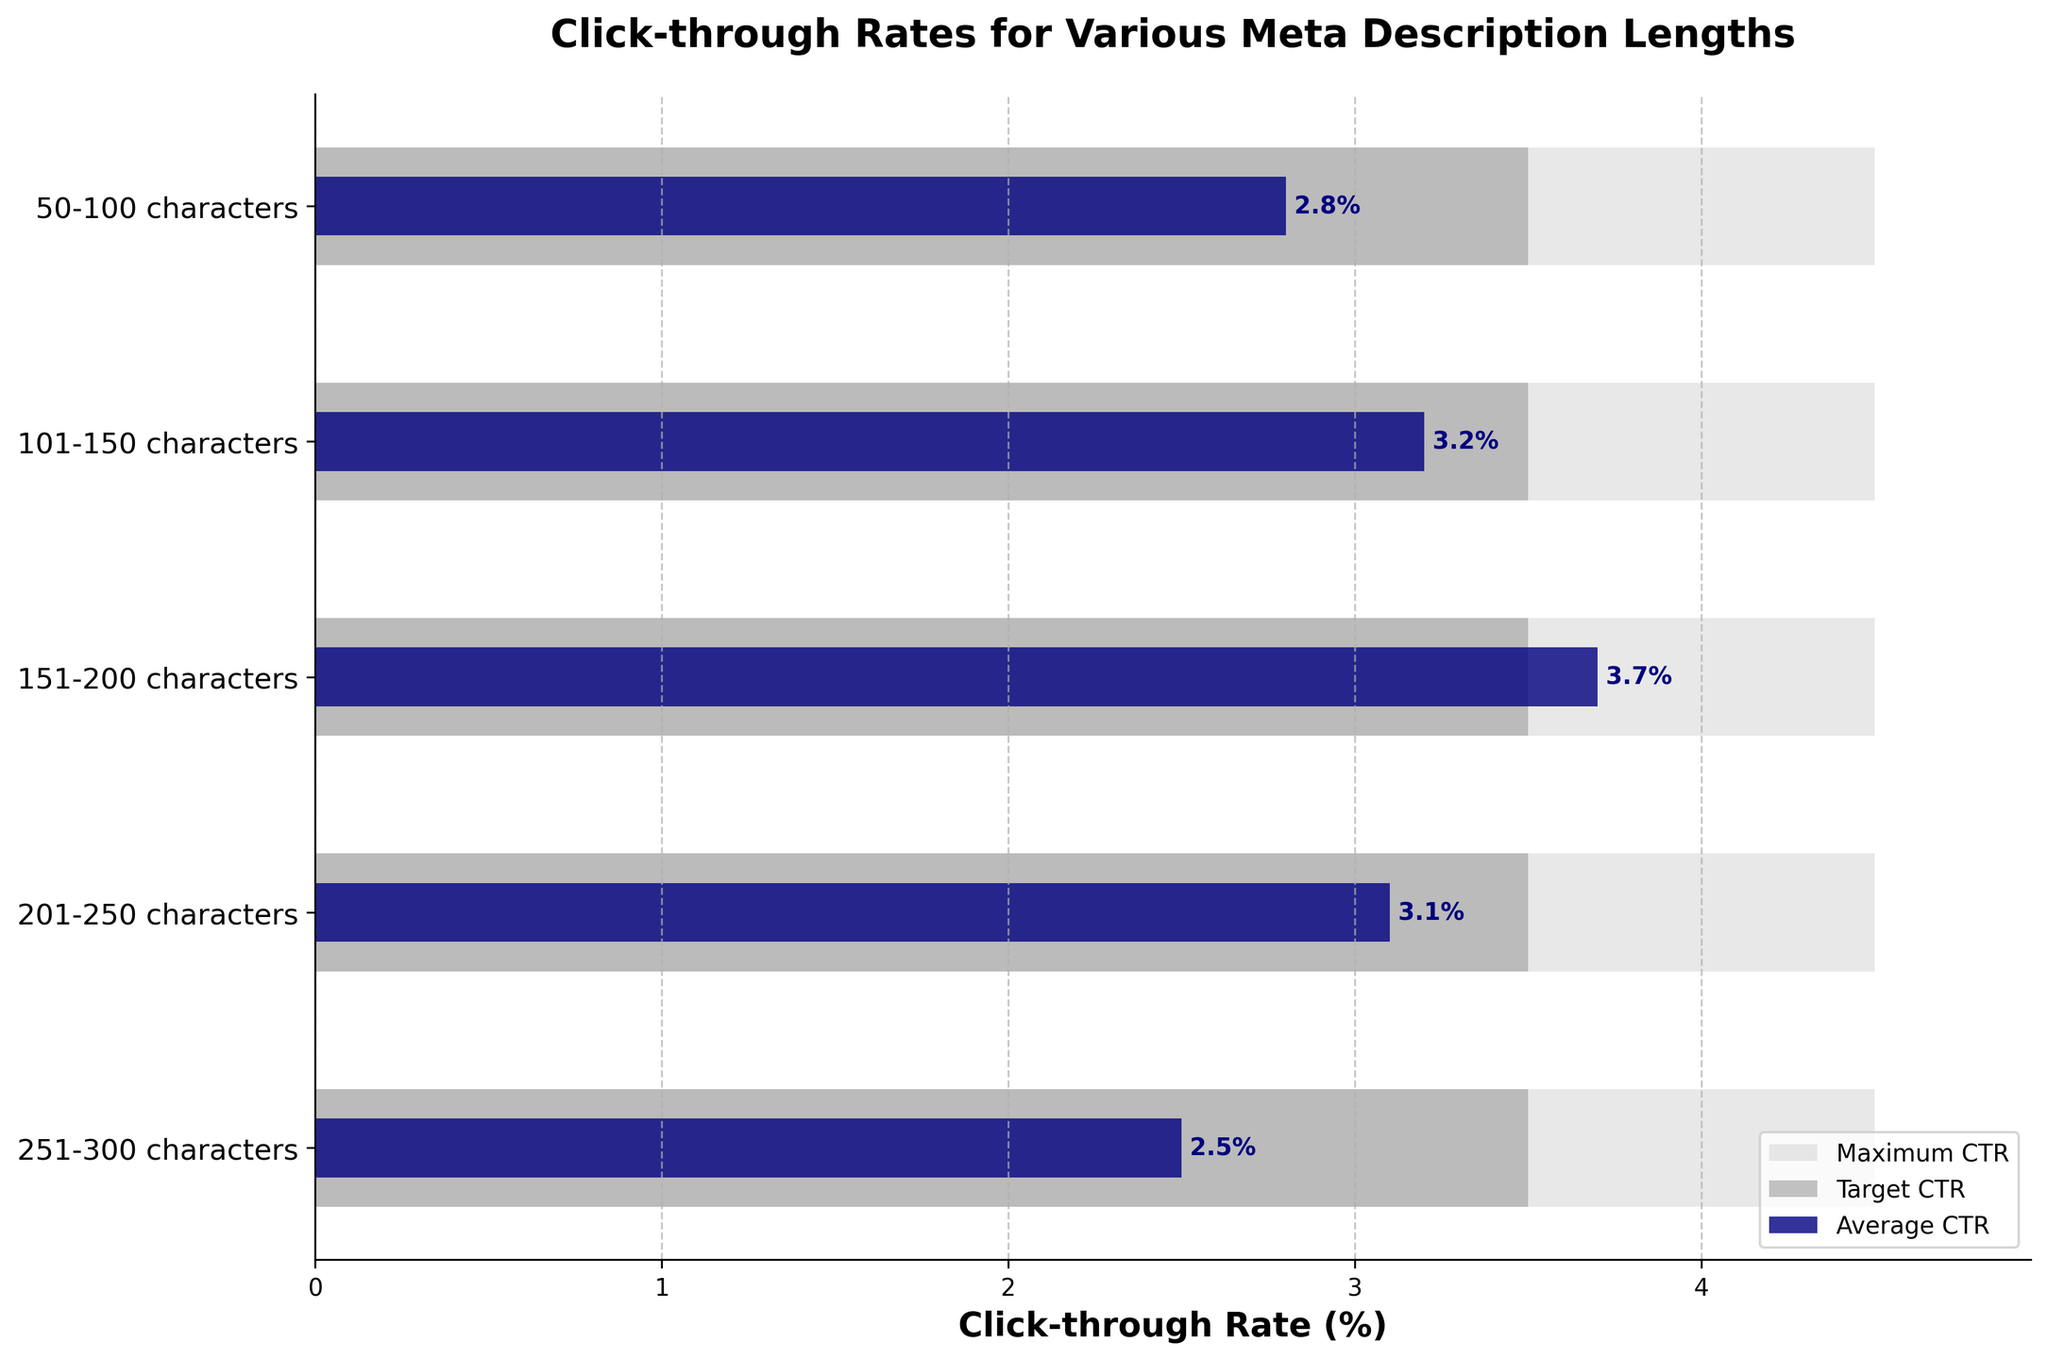What is the title of the chart? The title of the chart is displayed at the top and reads "Click-through Rates for Various Meta Description Lengths."
Answer: Click-through Rates for Various Meta Description Lengths What is the highest click-through rate in the chart? The highest click-through rate in the chart is given by the maximum CTR bar, which all reach up to 4.5%.
Answer: 4.5% How many meta description length categories are shown in the chart? The y-axis shows all the meta description length categories, and there are 5 such categories listed.
Answer: 5 Which meta description length category has the highest average CTR? To find the highest average CTR, we look at the navy-colored bars and see that the "151-200 characters" category has the highest average CTR of 3.7%.
Answer: 151-200 characters Which meta description length category has the lowest average CTR? By inspecting the navy-colored bars, the "251-300 characters" category has the lowest average CTR with a value of 2.5%.
Answer: 251-300 characters How does the average CTR for 201-250 characters compare to its target CTR? The average CTR for 201-250 characters is 3.1%, which is below its target CTR of 3.5%.
Answer: Below What is the difference between the maximum CTR and the average CTR for the 50-100 characters category? The maximum CTR for the 50-100 characters category is 4.5%, and the average CTR is 2.8%. The difference is calculated as 4.5% - 2.8% = 1.7%.
Answer: 1.7% Which meta description lengths have average CTRs exceeding their target CTRs? By comparing the navy-colored average CTR bars to the dark-grey target CTR bars, only the "151-200 characters" category has an average CTR (3.7%) exceeding its target CTR (3.5%).
Answer: 151-200 characters What is the range of average CTRs across all meta description length categories? The range is found by subtracting the smallest average CTR from the largest average CTR. The largest average CTR is 3.7% (from 151-200 characters) and the smallest is 2.5% (from 251-300 characters). The range is 3.7% - 2.5% = 1.2%.
Answer: 1.2% How close are the average CTRs for the 101-150 characters and 201-250 characters categories? The average CTR for the 101-150 characters category is 3.2%, and for the 201-250 characters category, it is 3.1%. The difference between these two values is 3.2% - 3.1% = 0.1%.
Answer: 0.1% 